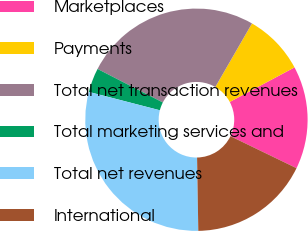Convert chart. <chart><loc_0><loc_0><loc_500><loc_500><pie_chart><fcel>Marketplaces<fcel>Payments<fcel>Total net transaction revenues<fcel>Total marketing services and<fcel>Total net revenues<fcel>International<nl><fcel>14.98%<fcel>8.87%<fcel>25.78%<fcel>3.52%<fcel>29.3%<fcel>17.56%<nl></chart> 